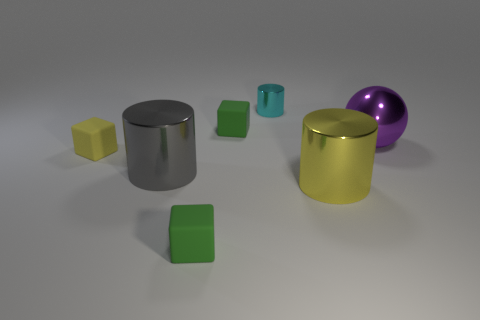The ball that is the same material as the tiny cyan thing is what color?
Your answer should be compact. Purple. How many small cylinders are the same material as the gray thing?
Ensure brevity in your answer.  1. There is a green cube that is behind the yellow shiny object; is it the same size as the cylinder that is on the right side of the tiny cyan metal cylinder?
Provide a succinct answer. No. What is the green block in front of the small green cube that is behind the metallic ball made of?
Give a very brief answer. Rubber. Is the number of green rubber objects that are behind the big gray metal thing less than the number of small matte objects to the right of the small yellow rubber cube?
Give a very brief answer. Yes. Is there anything else that has the same shape as the purple shiny thing?
Keep it short and to the point. No. There is a small green block in front of the yellow metallic thing; what is it made of?
Provide a short and direct response. Rubber. Are there any large metal things in front of the sphere?
Provide a succinct answer. Yes. There is a purple metallic thing; what shape is it?
Ensure brevity in your answer.  Sphere. What number of objects are cylinders to the left of the tiny cyan object or large brown matte objects?
Offer a terse response. 1. 